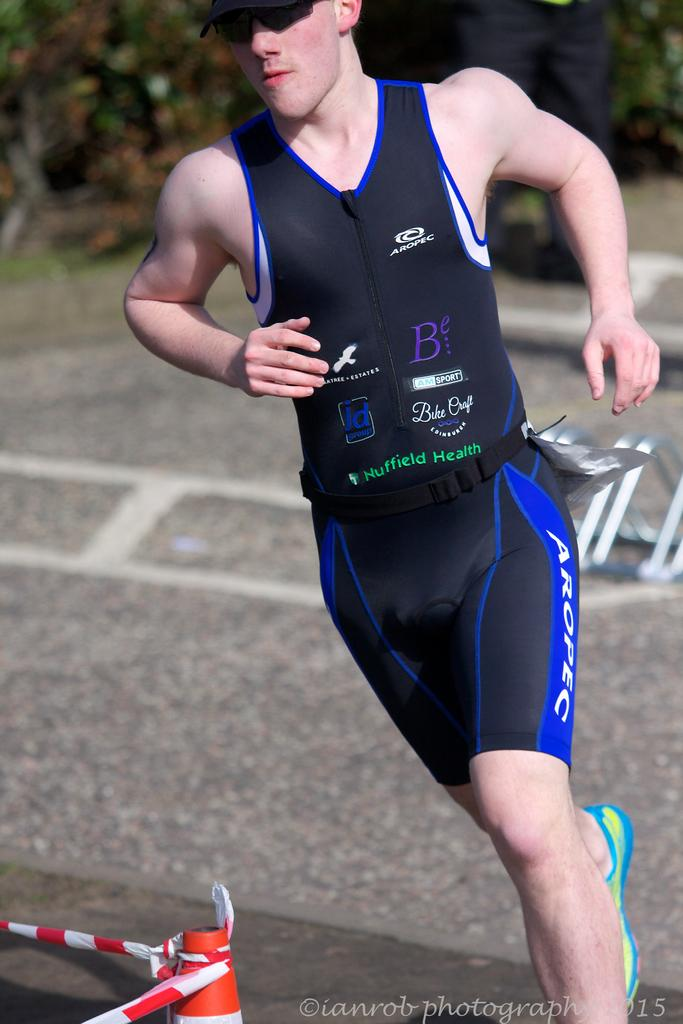<image>
Offer a succinct explanation of the picture presented. a runner in black aropec wear turning a corner. 